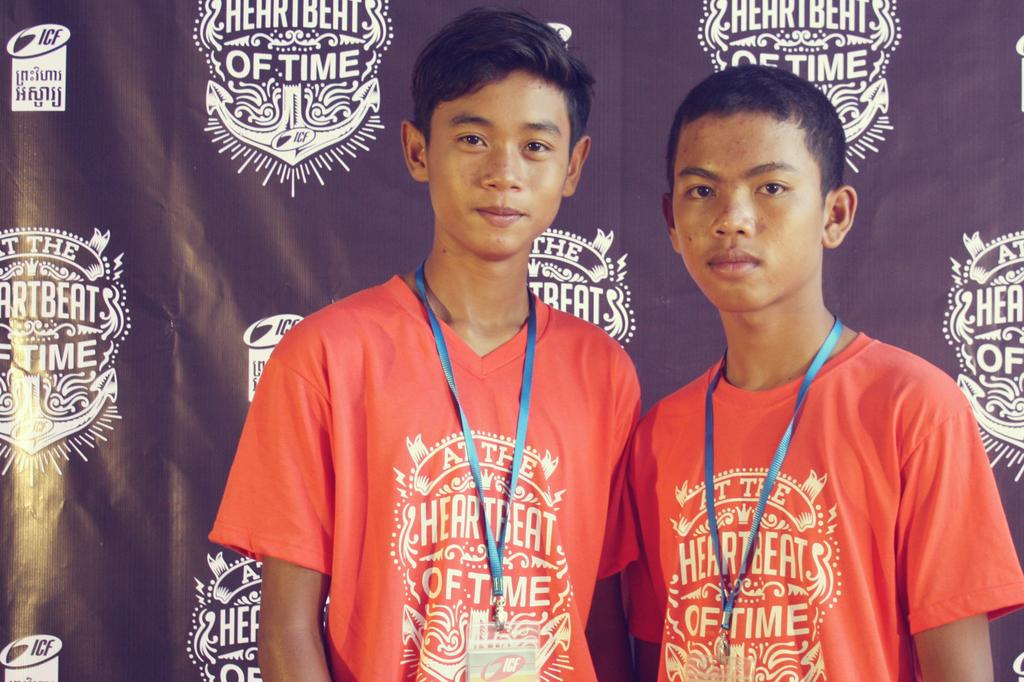What is the name of the sponsor?
Your answer should be compact. Heartbeats of time. What does the shirts say?
Give a very brief answer. Heartbeat of time. 